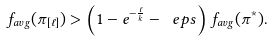Convert formula to latex. <formula><loc_0><loc_0><loc_500><loc_500>f _ { a v g } ( \pi _ { [ \ell ] } ) > \left ( 1 - e ^ { - \frac { \ell } { k } } - \ e p s \right ) f _ { a v g } ( \pi ^ { * } ) .</formula> 